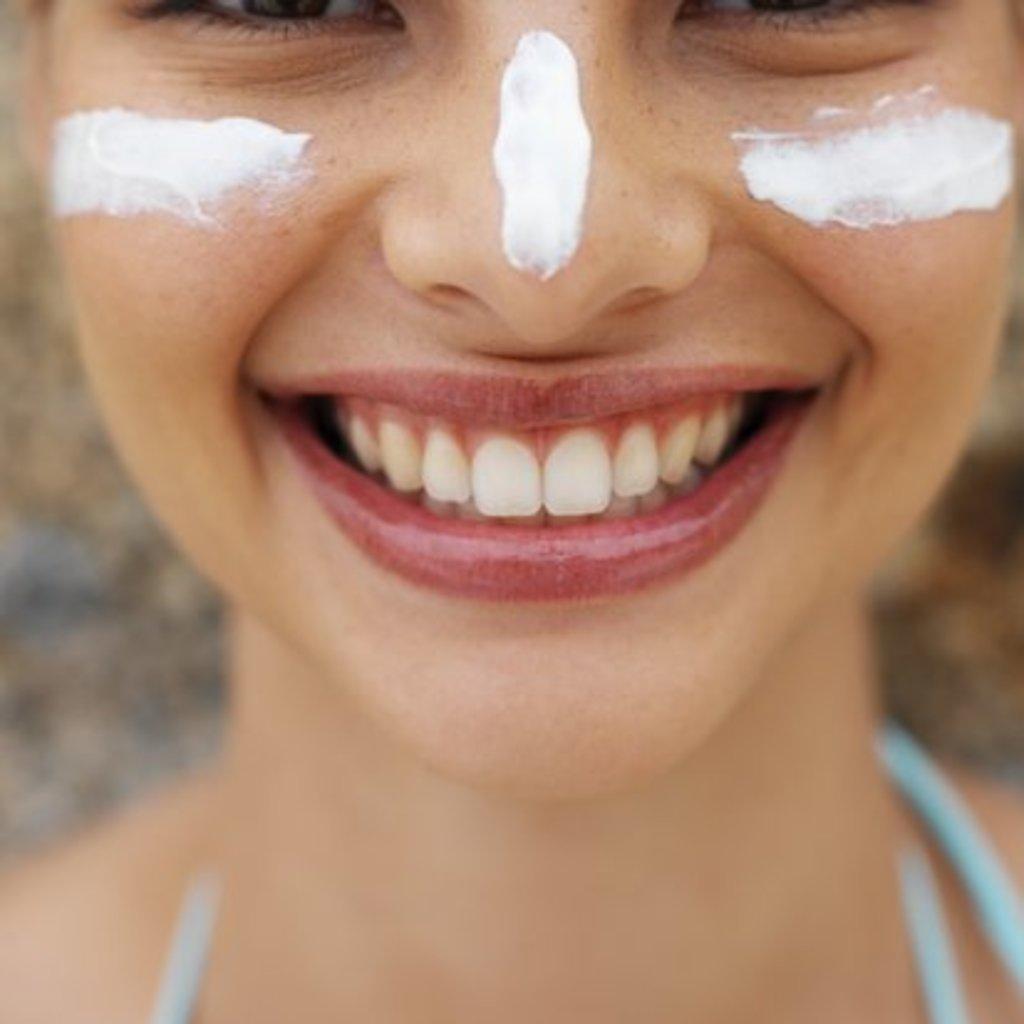How would you summarize this image in a sentence or two? In this image we can see a woman's face, there is cream on the face, the background of the image is blurred. 